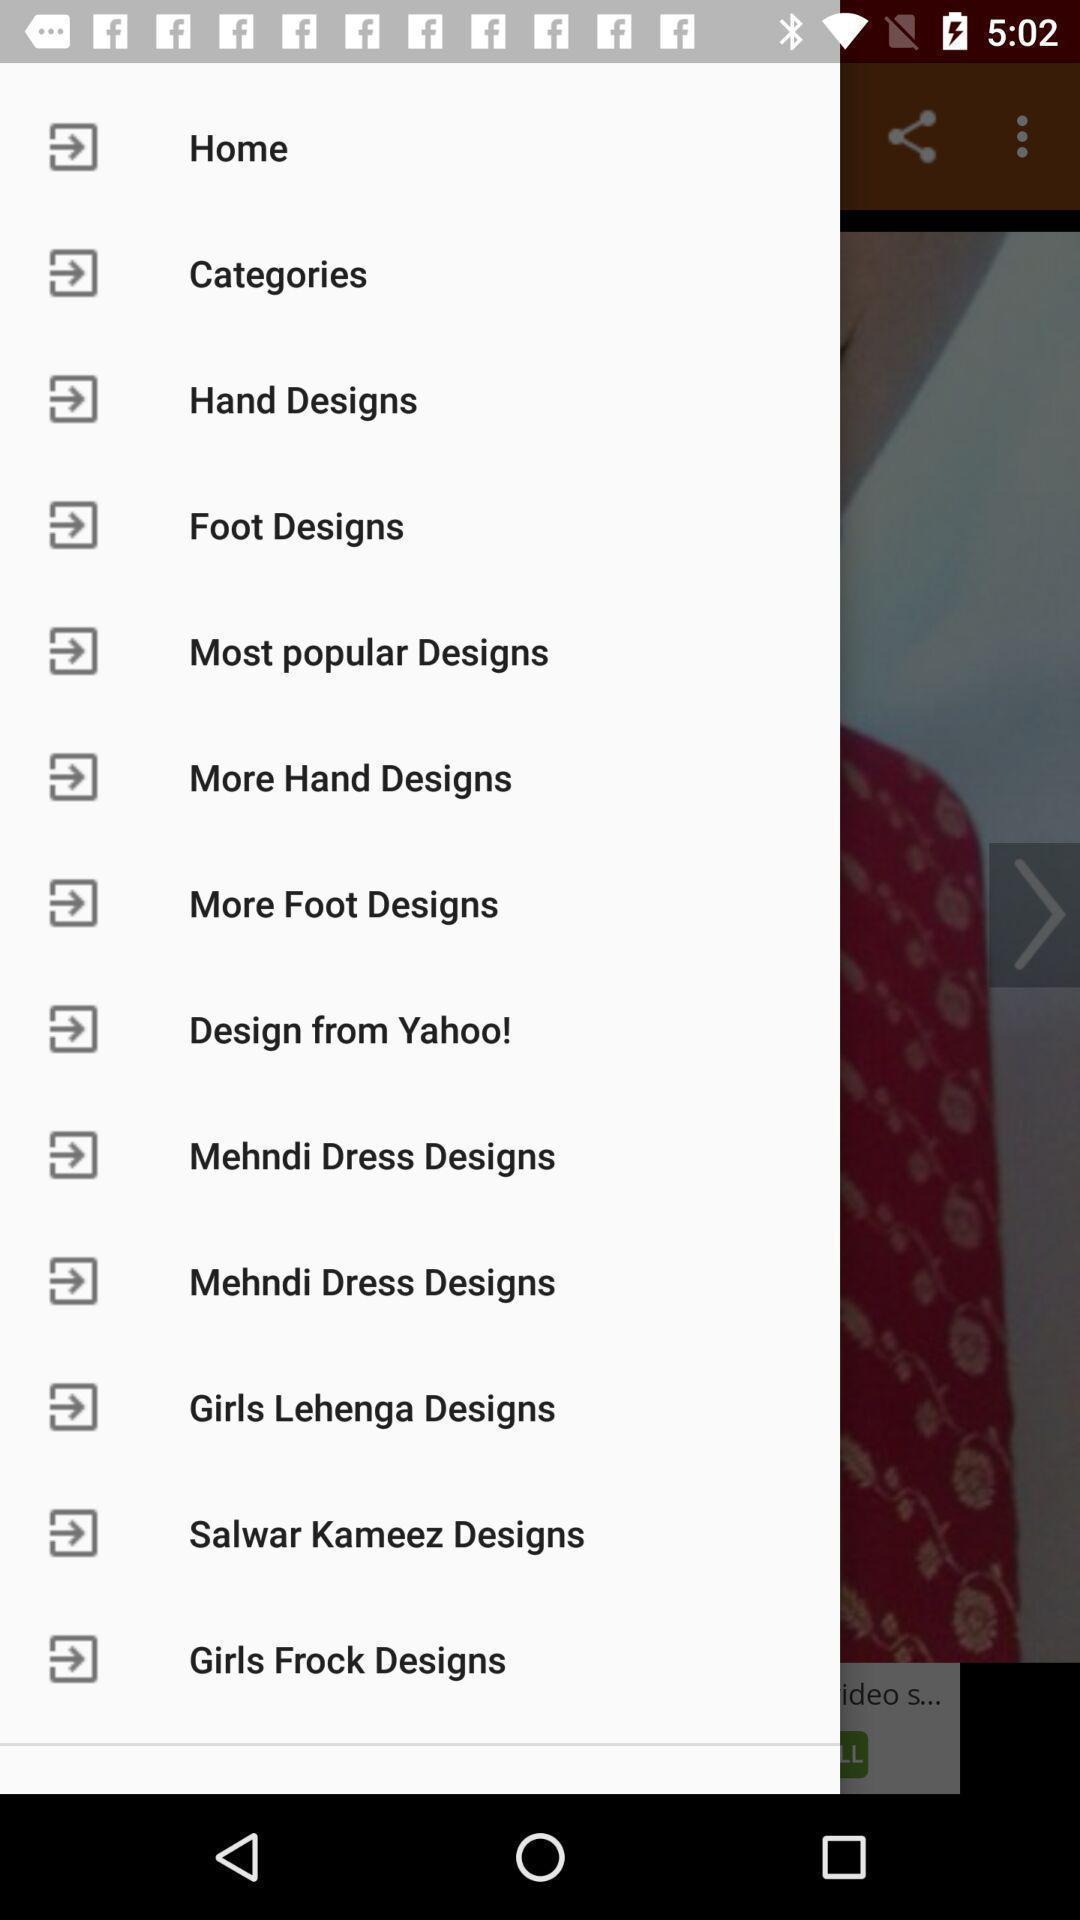Describe the key features of this screenshot. Menu list of designs. 